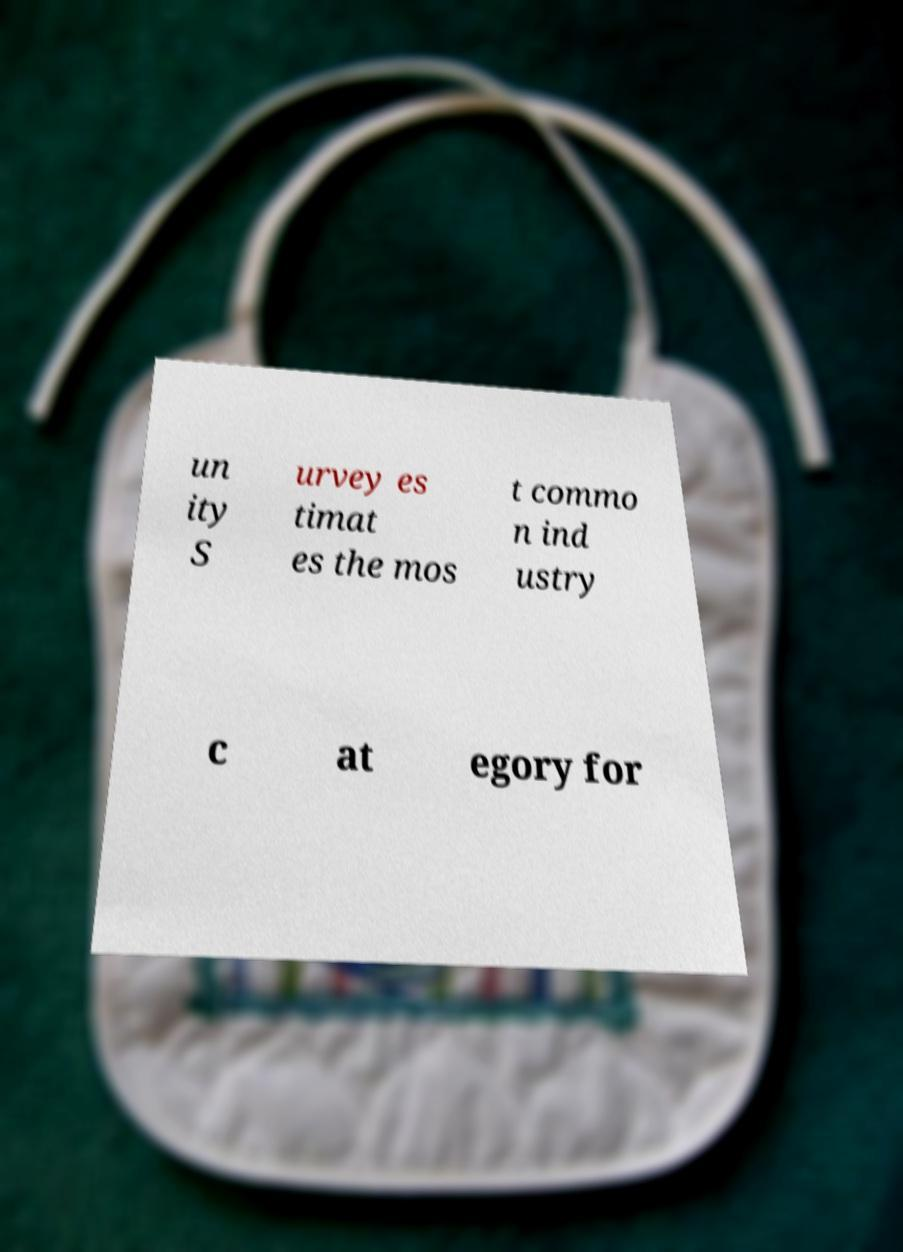What messages or text are displayed in this image? I need them in a readable, typed format. un ity S urvey es timat es the mos t commo n ind ustry c at egory for 